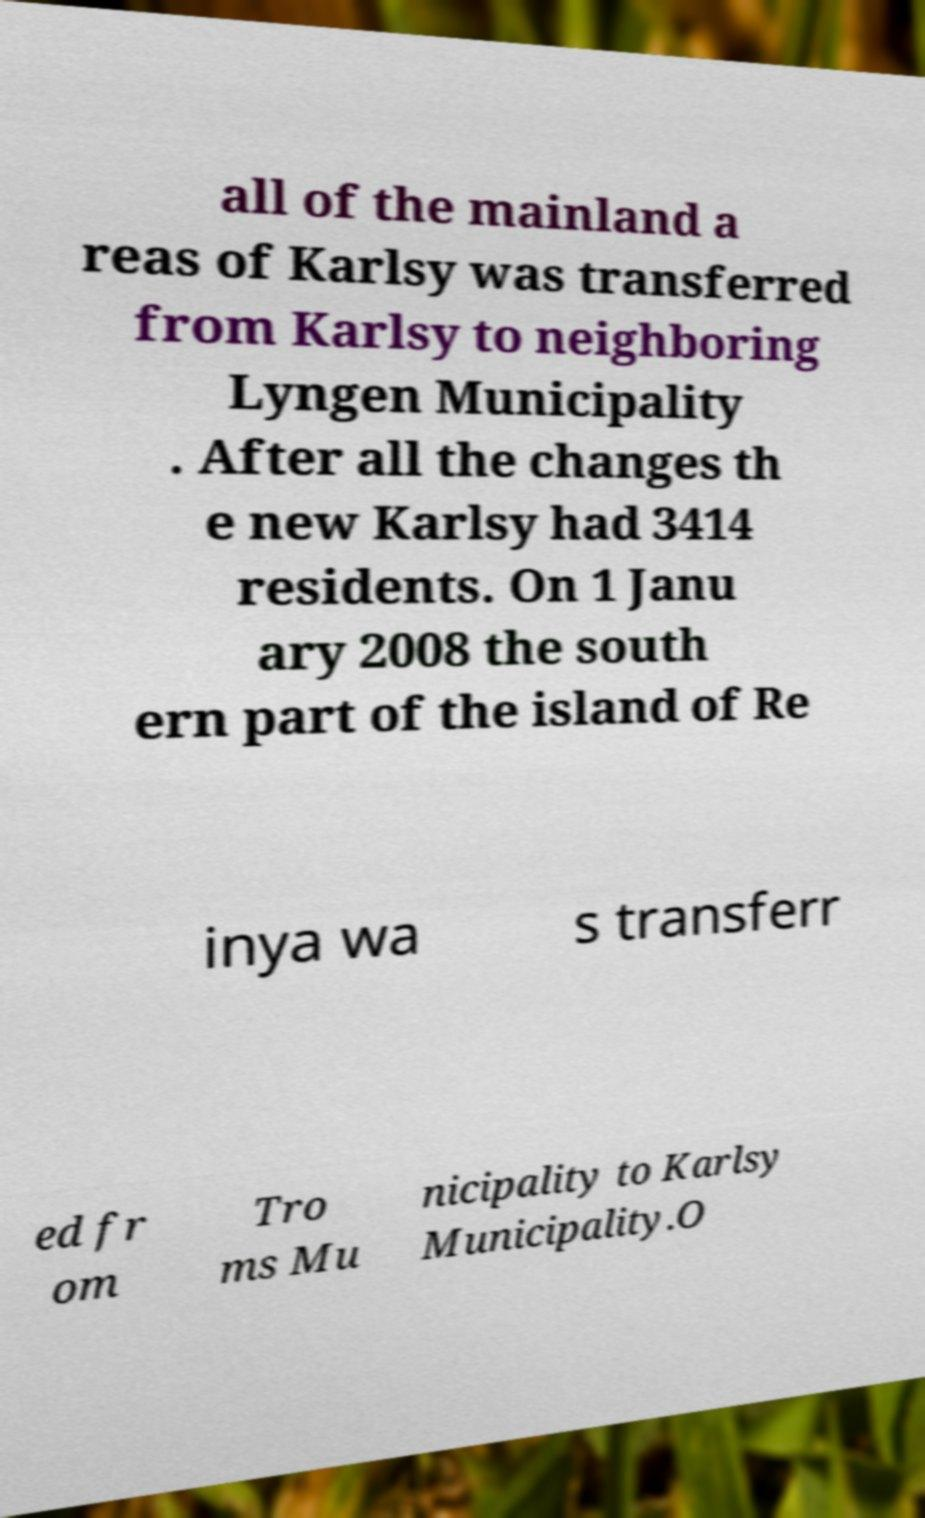There's text embedded in this image that I need extracted. Can you transcribe it verbatim? all of the mainland a reas of Karlsy was transferred from Karlsy to neighboring Lyngen Municipality . After all the changes th e new Karlsy had 3414 residents. On 1 Janu ary 2008 the south ern part of the island of Re inya wa s transferr ed fr om Tro ms Mu nicipality to Karlsy Municipality.O 